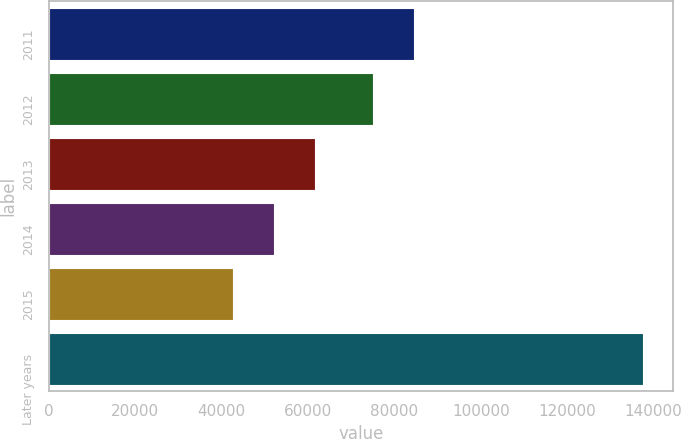Convert chart. <chart><loc_0><loc_0><loc_500><loc_500><bar_chart><fcel>2011<fcel>2012<fcel>2013<fcel>2014<fcel>2015<fcel>Later years<nl><fcel>84518.1<fcel>75033<fcel>61711.2<fcel>52226.1<fcel>42741<fcel>137592<nl></chart> 